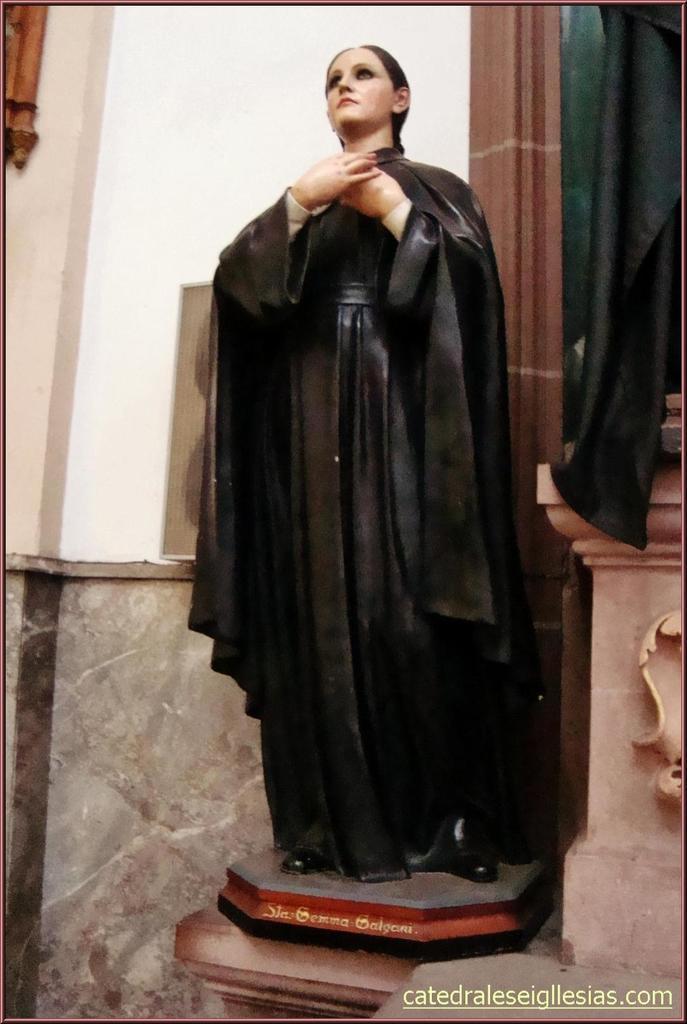How would you summarize this image in a sentence or two? This is the statue of the woman standing with the black dress. This looks like a wall. I think this is the pillar. I can see the watermark on the image. 